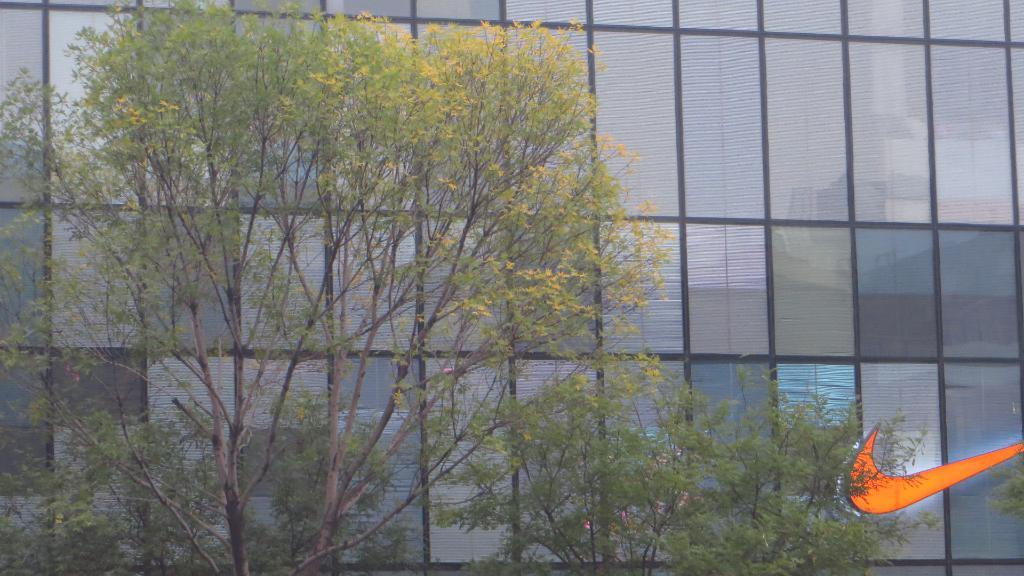What type of vegetation can be seen in the image? There are trees in the image. What structure is visible in the background of the image? There is a building in the background of the image. Where is the logo located in the image? The logo is in the right bottom corner of the image. What type of music can be heard coming from the trees in the image? There is no music present in the image, as it features trees and a building. How does the visitor interact with the logo in the image? There is no visitor present in the image, so it is not possible to determine how they might interact with the logo. 